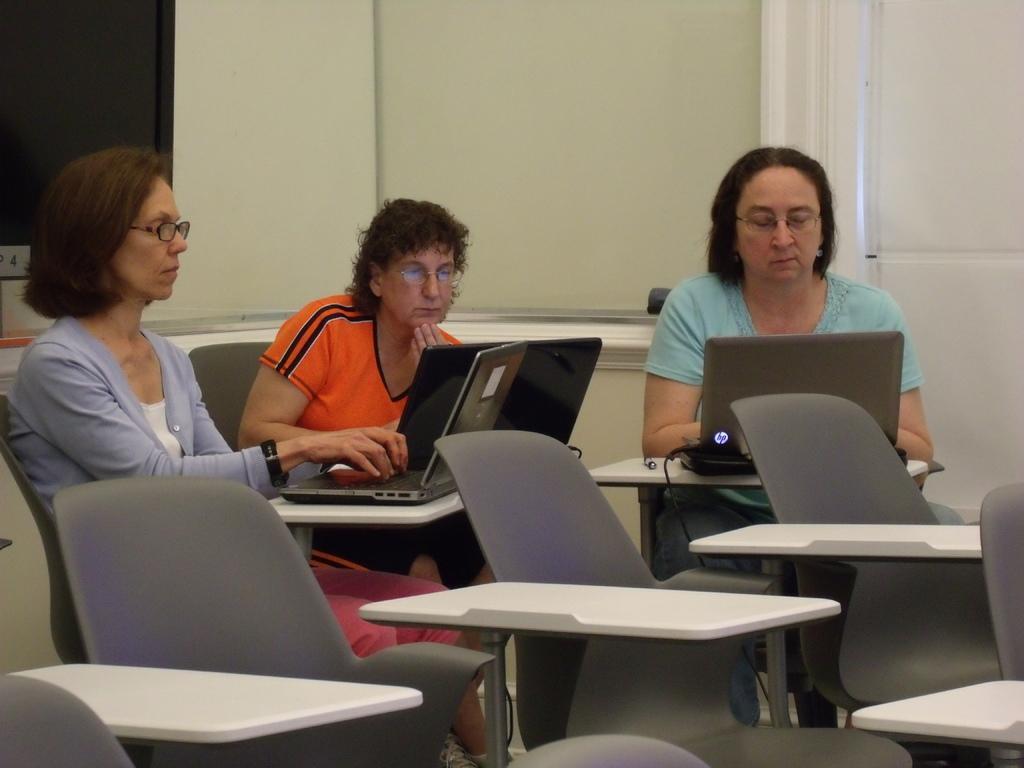Can you describe this image briefly? In this image I can see three women are sitting on chairs. I can also see laptops in front of them. Here I can see all of them are wearing specs and here I can see few more chairs. In the background I can see a television. 